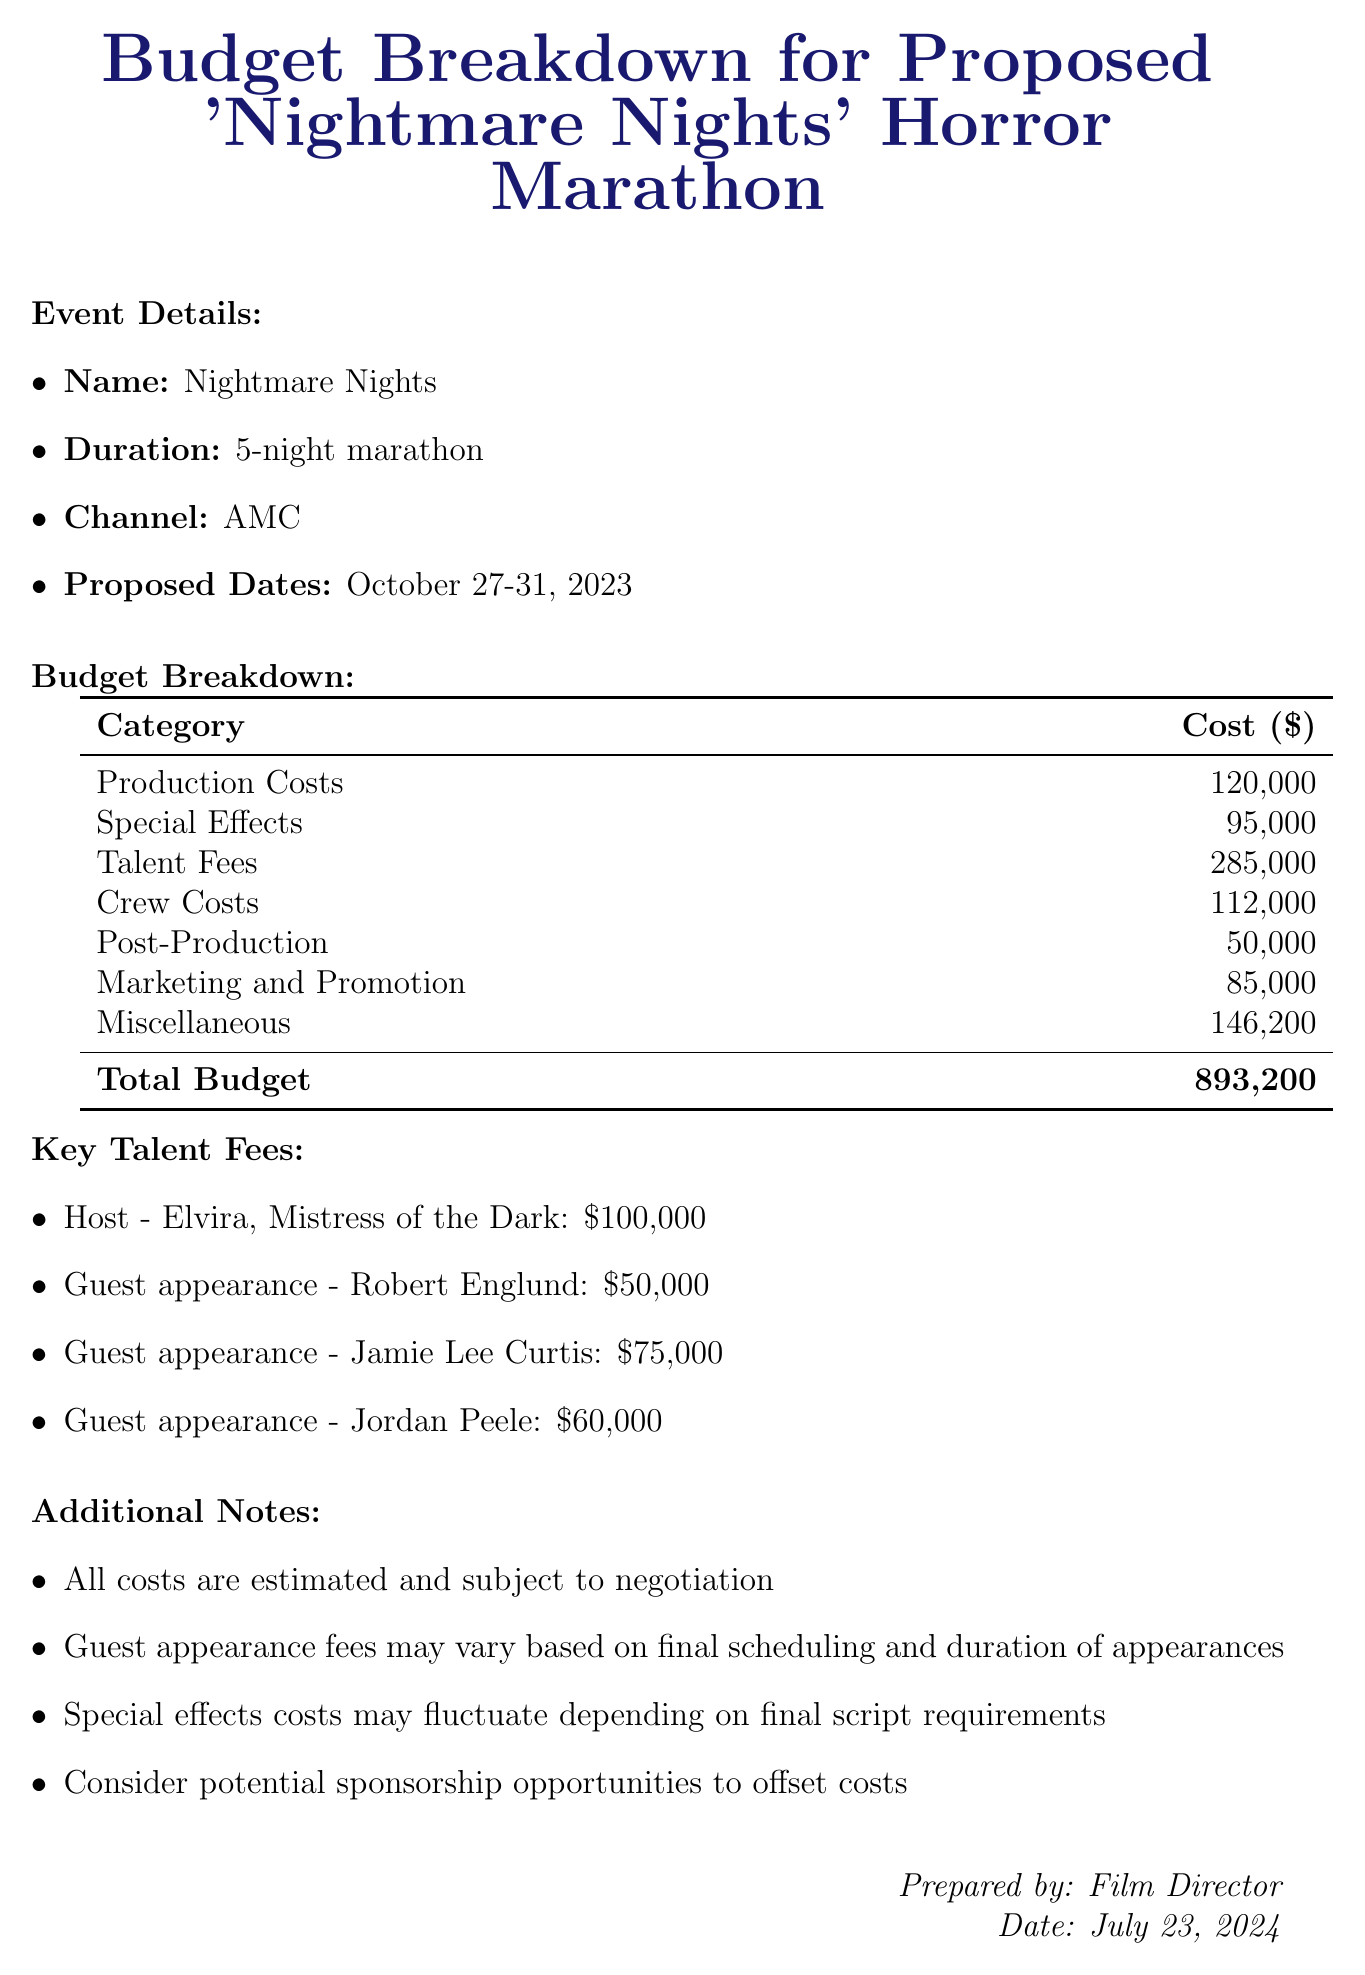What is the total budget for the marathon? The total budget is explicitly mentioned in the document as the final calculated cost for the event, which is $893,200.
Answer: $893,200 Who is the host of the marathon? The document lists the host of the "Nightmare Nights" as Elvira, Mistress of the Dark under the Talent Fees section.
Answer: Elvira, Mistress of the Dark What are the proposed dates for the marathon? The document specifies the potential scheduling of the event as October 27-31, 2023, in the event details section.
Answer: October 27-31, 2023 How much is allocated for marketing and promotion? The budget breakdown indicates a specific cost associated with marketing and promotion, which is $85,000.
Answer: $85,000 What items are included in the special effects category? The special effects category comprises several items, including practical effects, CGI and visual effects, and pyrotechnics.
Answer: Practical effects, CGI and visual effects, Pyrotechnics How much does a guest appearance by Jamie Lee Curtis cost? The document lists Jamie Lee Curtis's guest appearance fee specifically as $75,000 and highlights it under the Talent Fees category.
Answer: $75,000 What is the cost for set design and construction? The cost for set design and construction is clearly stated in the Production Costs section as $75,000.
Answer: $75,000 What is included in the miscellaneous category? The miscellaneous category contains various items including catering, transportation, insurance, and a contingency fund, indicating diverse expenses.
Answer: Catering, Transportation, Insurance, Contingency fund What does the contingency fund represent in the budget? The document describes the contingency fund as 10% of the total estimated budget, highlighting its purpose as a reserve for unexpected expenses.
Answer: 10% 